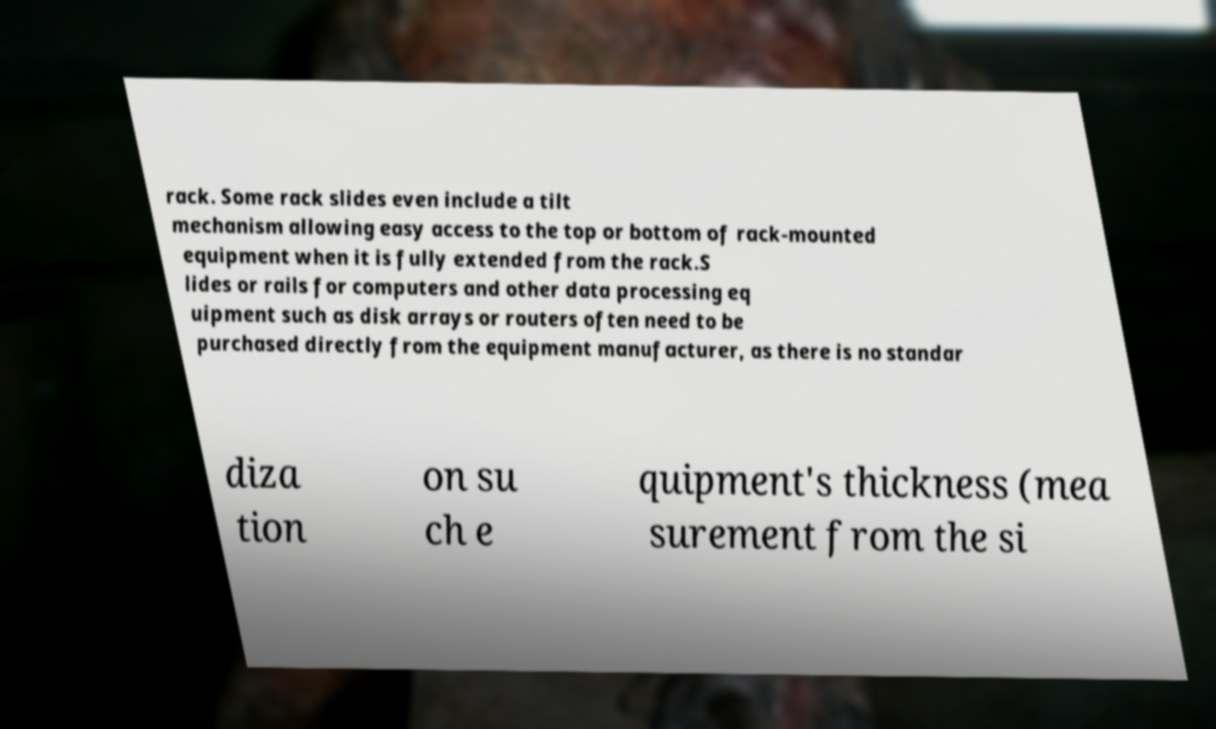Can you read and provide the text displayed in the image?This photo seems to have some interesting text. Can you extract and type it out for me? rack. Some rack slides even include a tilt mechanism allowing easy access to the top or bottom of rack-mounted equipment when it is fully extended from the rack.S lides or rails for computers and other data processing eq uipment such as disk arrays or routers often need to be purchased directly from the equipment manufacturer, as there is no standar diza tion on su ch e quipment's thickness (mea surement from the si 